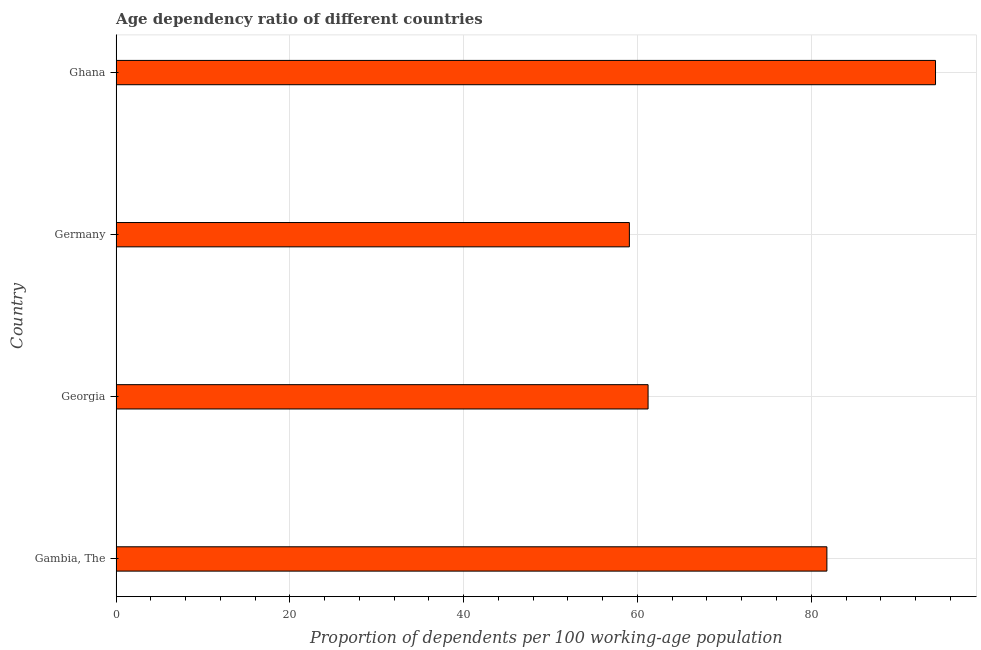Does the graph contain any zero values?
Provide a succinct answer. No. Does the graph contain grids?
Provide a short and direct response. Yes. What is the title of the graph?
Keep it short and to the point. Age dependency ratio of different countries. What is the label or title of the X-axis?
Keep it short and to the point. Proportion of dependents per 100 working-age population. What is the age dependency ratio in Ghana?
Your response must be concise. 94.3. Across all countries, what is the maximum age dependency ratio?
Give a very brief answer. 94.3. Across all countries, what is the minimum age dependency ratio?
Keep it short and to the point. 59.07. In which country was the age dependency ratio maximum?
Provide a short and direct response. Ghana. What is the sum of the age dependency ratio?
Provide a succinct answer. 296.4. What is the difference between the age dependency ratio in Georgia and Ghana?
Offer a very short reply. -33.08. What is the average age dependency ratio per country?
Give a very brief answer. 74.1. What is the median age dependency ratio?
Offer a terse response. 71.51. What is the ratio of the age dependency ratio in Georgia to that in Germany?
Provide a succinct answer. 1.04. Is the difference between the age dependency ratio in Gambia, The and Ghana greater than the difference between any two countries?
Your response must be concise. No. What is the difference between the highest and the second highest age dependency ratio?
Provide a short and direct response. 12.5. Is the sum of the age dependency ratio in Georgia and Ghana greater than the maximum age dependency ratio across all countries?
Provide a succinct answer. Yes. What is the difference between the highest and the lowest age dependency ratio?
Ensure brevity in your answer.  35.23. In how many countries, is the age dependency ratio greater than the average age dependency ratio taken over all countries?
Ensure brevity in your answer.  2. How many countries are there in the graph?
Provide a succinct answer. 4. What is the difference between two consecutive major ticks on the X-axis?
Ensure brevity in your answer.  20. What is the Proportion of dependents per 100 working-age population of Gambia, The?
Keep it short and to the point. 81.8. What is the Proportion of dependents per 100 working-age population in Georgia?
Ensure brevity in your answer.  61.22. What is the Proportion of dependents per 100 working-age population in Germany?
Make the answer very short. 59.07. What is the Proportion of dependents per 100 working-age population of Ghana?
Offer a very short reply. 94.3. What is the difference between the Proportion of dependents per 100 working-age population in Gambia, The and Georgia?
Your answer should be compact. 20.58. What is the difference between the Proportion of dependents per 100 working-age population in Gambia, The and Germany?
Offer a terse response. 22.73. What is the difference between the Proportion of dependents per 100 working-age population in Gambia, The and Ghana?
Ensure brevity in your answer.  -12.5. What is the difference between the Proportion of dependents per 100 working-age population in Georgia and Germany?
Your response must be concise. 2.15. What is the difference between the Proportion of dependents per 100 working-age population in Georgia and Ghana?
Make the answer very short. -33.08. What is the difference between the Proportion of dependents per 100 working-age population in Germany and Ghana?
Provide a short and direct response. -35.23. What is the ratio of the Proportion of dependents per 100 working-age population in Gambia, The to that in Georgia?
Give a very brief answer. 1.34. What is the ratio of the Proportion of dependents per 100 working-age population in Gambia, The to that in Germany?
Offer a very short reply. 1.39. What is the ratio of the Proportion of dependents per 100 working-age population in Gambia, The to that in Ghana?
Ensure brevity in your answer.  0.87. What is the ratio of the Proportion of dependents per 100 working-age population in Georgia to that in Germany?
Ensure brevity in your answer.  1.04. What is the ratio of the Proportion of dependents per 100 working-age population in Georgia to that in Ghana?
Offer a very short reply. 0.65. What is the ratio of the Proportion of dependents per 100 working-age population in Germany to that in Ghana?
Your response must be concise. 0.63. 